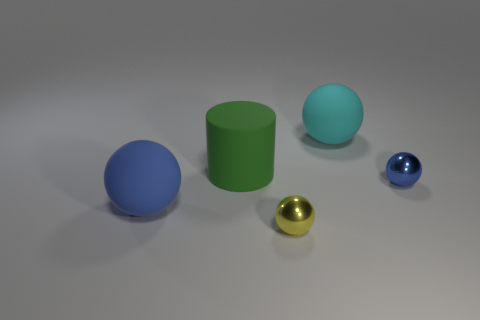Add 5 yellow things. How many objects exist? 10 Subtract all cylinders. How many objects are left? 4 Add 4 big cyan shiny objects. How many big cyan shiny objects exist? 4 Subtract 1 yellow balls. How many objects are left? 4 Subtract all large blue cubes. Subtract all balls. How many objects are left? 1 Add 2 shiny objects. How many shiny objects are left? 4 